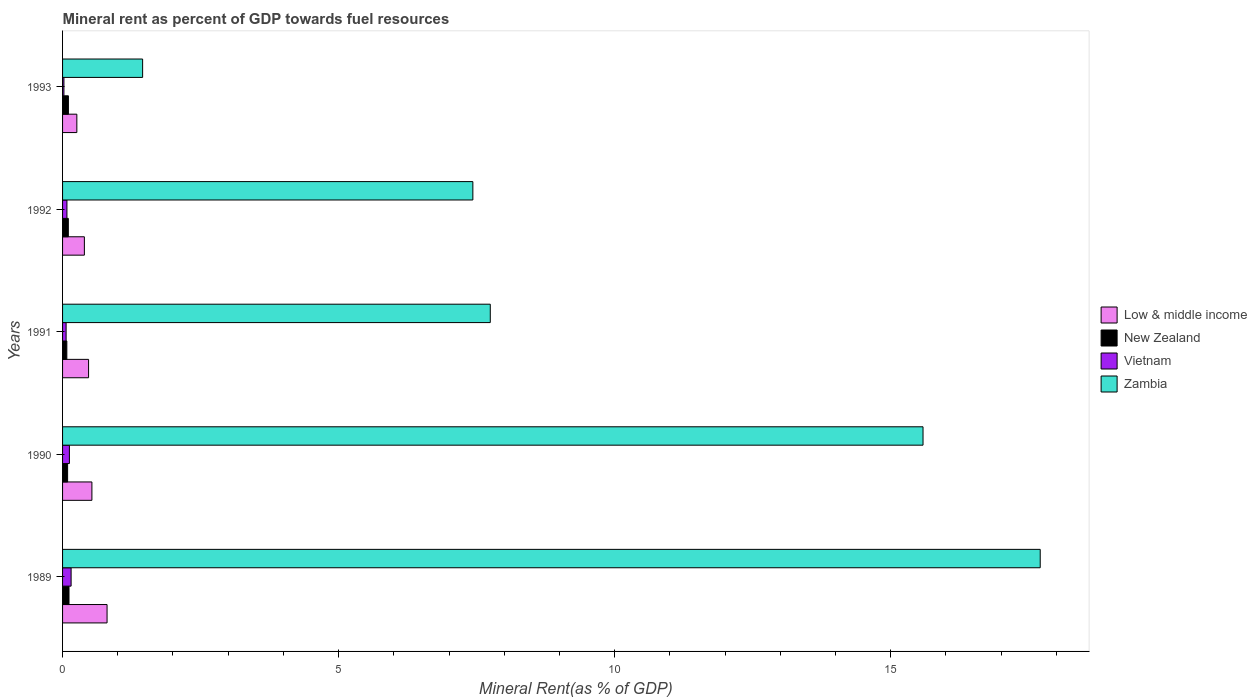How many different coloured bars are there?
Ensure brevity in your answer.  4. How many bars are there on the 3rd tick from the bottom?
Provide a succinct answer. 4. What is the mineral rent in Low & middle income in 1990?
Offer a very short reply. 0.53. Across all years, what is the maximum mineral rent in New Zealand?
Your response must be concise. 0.12. Across all years, what is the minimum mineral rent in Low & middle income?
Provide a short and direct response. 0.26. In which year was the mineral rent in Zambia maximum?
Give a very brief answer. 1989. What is the total mineral rent in Vietnam in the graph?
Provide a short and direct response. 0.45. What is the difference between the mineral rent in New Zealand in 1989 and that in 1993?
Give a very brief answer. 0.01. What is the difference between the mineral rent in Vietnam in 1992 and the mineral rent in Low & middle income in 1989?
Make the answer very short. -0.73. What is the average mineral rent in New Zealand per year?
Provide a succinct answer. 0.1. In the year 1993, what is the difference between the mineral rent in New Zealand and mineral rent in Zambia?
Make the answer very short. -1.34. In how many years, is the mineral rent in Zambia greater than 7 %?
Provide a succinct answer. 4. What is the ratio of the mineral rent in Low & middle income in 1990 to that in 1991?
Offer a very short reply. 1.13. What is the difference between the highest and the second highest mineral rent in Zambia?
Give a very brief answer. 2.12. What is the difference between the highest and the lowest mineral rent in Zambia?
Your answer should be compact. 16.26. What does the 1st bar from the top in 1993 represents?
Offer a terse response. Zambia. Is it the case that in every year, the sum of the mineral rent in Zambia and mineral rent in Low & middle income is greater than the mineral rent in Vietnam?
Offer a very short reply. Yes. How many bars are there?
Make the answer very short. 20. How many years are there in the graph?
Provide a short and direct response. 5. What is the difference between two consecutive major ticks on the X-axis?
Keep it short and to the point. 5. Are the values on the major ticks of X-axis written in scientific E-notation?
Ensure brevity in your answer.  No. Does the graph contain grids?
Your response must be concise. No. How are the legend labels stacked?
Offer a terse response. Vertical. What is the title of the graph?
Make the answer very short. Mineral rent as percent of GDP towards fuel resources. Does "Sweden" appear as one of the legend labels in the graph?
Your response must be concise. No. What is the label or title of the X-axis?
Your answer should be compact. Mineral Rent(as % of GDP). What is the label or title of the Y-axis?
Give a very brief answer. Years. What is the Mineral Rent(as % of GDP) of Low & middle income in 1989?
Ensure brevity in your answer.  0.81. What is the Mineral Rent(as % of GDP) in New Zealand in 1989?
Provide a succinct answer. 0.12. What is the Mineral Rent(as % of GDP) of Vietnam in 1989?
Your answer should be compact. 0.15. What is the Mineral Rent(as % of GDP) in Zambia in 1989?
Your response must be concise. 17.71. What is the Mineral Rent(as % of GDP) of Low & middle income in 1990?
Provide a succinct answer. 0.53. What is the Mineral Rent(as % of GDP) in New Zealand in 1990?
Keep it short and to the point. 0.09. What is the Mineral Rent(as % of GDP) of Vietnam in 1990?
Offer a terse response. 0.12. What is the Mineral Rent(as % of GDP) in Zambia in 1990?
Provide a succinct answer. 15.59. What is the Mineral Rent(as % of GDP) in Low & middle income in 1991?
Your answer should be very brief. 0.47. What is the Mineral Rent(as % of GDP) of New Zealand in 1991?
Your answer should be very brief. 0.08. What is the Mineral Rent(as % of GDP) in Vietnam in 1991?
Ensure brevity in your answer.  0.06. What is the Mineral Rent(as % of GDP) of Zambia in 1991?
Your answer should be very brief. 7.75. What is the Mineral Rent(as % of GDP) in Low & middle income in 1992?
Provide a succinct answer. 0.4. What is the Mineral Rent(as % of GDP) of New Zealand in 1992?
Your response must be concise. 0.1. What is the Mineral Rent(as % of GDP) of Vietnam in 1992?
Offer a terse response. 0.08. What is the Mineral Rent(as % of GDP) in Zambia in 1992?
Offer a terse response. 7.43. What is the Mineral Rent(as % of GDP) of Low & middle income in 1993?
Ensure brevity in your answer.  0.26. What is the Mineral Rent(as % of GDP) in New Zealand in 1993?
Keep it short and to the point. 0.11. What is the Mineral Rent(as % of GDP) of Vietnam in 1993?
Give a very brief answer. 0.02. What is the Mineral Rent(as % of GDP) in Zambia in 1993?
Keep it short and to the point. 1.45. Across all years, what is the maximum Mineral Rent(as % of GDP) of Low & middle income?
Ensure brevity in your answer.  0.81. Across all years, what is the maximum Mineral Rent(as % of GDP) of New Zealand?
Give a very brief answer. 0.12. Across all years, what is the maximum Mineral Rent(as % of GDP) of Vietnam?
Provide a short and direct response. 0.15. Across all years, what is the maximum Mineral Rent(as % of GDP) in Zambia?
Your response must be concise. 17.71. Across all years, what is the minimum Mineral Rent(as % of GDP) in Low & middle income?
Your answer should be very brief. 0.26. Across all years, what is the minimum Mineral Rent(as % of GDP) in New Zealand?
Make the answer very short. 0.08. Across all years, what is the minimum Mineral Rent(as % of GDP) in Vietnam?
Give a very brief answer. 0.02. Across all years, what is the minimum Mineral Rent(as % of GDP) of Zambia?
Provide a succinct answer. 1.45. What is the total Mineral Rent(as % of GDP) of Low & middle income in the graph?
Provide a short and direct response. 2.46. What is the total Mineral Rent(as % of GDP) of New Zealand in the graph?
Your answer should be very brief. 0.5. What is the total Mineral Rent(as % of GDP) of Vietnam in the graph?
Your answer should be compact. 0.45. What is the total Mineral Rent(as % of GDP) of Zambia in the graph?
Give a very brief answer. 49.92. What is the difference between the Mineral Rent(as % of GDP) of Low & middle income in 1989 and that in 1990?
Make the answer very short. 0.27. What is the difference between the Mineral Rent(as % of GDP) of New Zealand in 1989 and that in 1990?
Make the answer very short. 0.03. What is the difference between the Mineral Rent(as % of GDP) in Vietnam in 1989 and that in 1990?
Provide a succinct answer. 0.03. What is the difference between the Mineral Rent(as % of GDP) in Zambia in 1989 and that in 1990?
Ensure brevity in your answer.  2.12. What is the difference between the Mineral Rent(as % of GDP) of Low & middle income in 1989 and that in 1991?
Keep it short and to the point. 0.34. What is the difference between the Mineral Rent(as % of GDP) in New Zealand in 1989 and that in 1991?
Your answer should be very brief. 0.04. What is the difference between the Mineral Rent(as % of GDP) of Vietnam in 1989 and that in 1991?
Offer a very short reply. 0.09. What is the difference between the Mineral Rent(as % of GDP) in Zambia in 1989 and that in 1991?
Provide a succinct answer. 9.96. What is the difference between the Mineral Rent(as % of GDP) of Low & middle income in 1989 and that in 1992?
Give a very brief answer. 0.41. What is the difference between the Mineral Rent(as % of GDP) of New Zealand in 1989 and that in 1992?
Your answer should be very brief. 0.01. What is the difference between the Mineral Rent(as % of GDP) in Vietnam in 1989 and that in 1992?
Ensure brevity in your answer.  0.08. What is the difference between the Mineral Rent(as % of GDP) in Zambia in 1989 and that in 1992?
Your response must be concise. 10.28. What is the difference between the Mineral Rent(as % of GDP) in Low & middle income in 1989 and that in 1993?
Keep it short and to the point. 0.55. What is the difference between the Mineral Rent(as % of GDP) of New Zealand in 1989 and that in 1993?
Make the answer very short. 0.01. What is the difference between the Mineral Rent(as % of GDP) in Vietnam in 1989 and that in 1993?
Your answer should be compact. 0.13. What is the difference between the Mineral Rent(as % of GDP) in Zambia in 1989 and that in 1993?
Make the answer very short. 16.26. What is the difference between the Mineral Rent(as % of GDP) in Low & middle income in 1990 and that in 1991?
Your answer should be very brief. 0.06. What is the difference between the Mineral Rent(as % of GDP) of New Zealand in 1990 and that in 1991?
Offer a terse response. 0.01. What is the difference between the Mineral Rent(as % of GDP) in Vietnam in 1990 and that in 1991?
Keep it short and to the point. 0.06. What is the difference between the Mineral Rent(as % of GDP) of Zambia in 1990 and that in 1991?
Give a very brief answer. 7.84. What is the difference between the Mineral Rent(as % of GDP) of Low & middle income in 1990 and that in 1992?
Ensure brevity in your answer.  0.14. What is the difference between the Mineral Rent(as % of GDP) in New Zealand in 1990 and that in 1992?
Provide a succinct answer. -0.01. What is the difference between the Mineral Rent(as % of GDP) of Vietnam in 1990 and that in 1992?
Offer a terse response. 0.04. What is the difference between the Mineral Rent(as % of GDP) in Zambia in 1990 and that in 1992?
Make the answer very short. 8.15. What is the difference between the Mineral Rent(as % of GDP) in Low & middle income in 1990 and that in 1993?
Ensure brevity in your answer.  0.27. What is the difference between the Mineral Rent(as % of GDP) of New Zealand in 1990 and that in 1993?
Offer a terse response. -0.01. What is the difference between the Mineral Rent(as % of GDP) of Vietnam in 1990 and that in 1993?
Your answer should be very brief. 0.1. What is the difference between the Mineral Rent(as % of GDP) of Zambia in 1990 and that in 1993?
Your answer should be compact. 14.14. What is the difference between the Mineral Rent(as % of GDP) in Low & middle income in 1991 and that in 1992?
Your answer should be very brief. 0.08. What is the difference between the Mineral Rent(as % of GDP) of New Zealand in 1991 and that in 1992?
Offer a terse response. -0.03. What is the difference between the Mineral Rent(as % of GDP) in Vietnam in 1991 and that in 1992?
Offer a very short reply. -0.01. What is the difference between the Mineral Rent(as % of GDP) of Zambia in 1991 and that in 1992?
Provide a succinct answer. 0.32. What is the difference between the Mineral Rent(as % of GDP) of Low & middle income in 1991 and that in 1993?
Make the answer very short. 0.21. What is the difference between the Mineral Rent(as % of GDP) of New Zealand in 1991 and that in 1993?
Offer a terse response. -0.03. What is the difference between the Mineral Rent(as % of GDP) of Vietnam in 1991 and that in 1993?
Provide a short and direct response. 0.04. What is the difference between the Mineral Rent(as % of GDP) of Zambia in 1991 and that in 1993?
Offer a very short reply. 6.3. What is the difference between the Mineral Rent(as % of GDP) of Low & middle income in 1992 and that in 1993?
Provide a short and direct response. 0.14. What is the difference between the Mineral Rent(as % of GDP) in New Zealand in 1992 and that in 1993?
Offer a very short reply. -0. What is the difference between the Mineral Rent(as % of GDP) in Vietnam in 1992 and that in 1993?
Your response must be concise. 0.05. What is the difference between the Mineral Rent(as % of GDP) of Zambia in 1992 and that in 1993?
Make the answer very short. 5.98. What is the difference between the Mineral Rent(as % of GDP) of Low & middle income in 1989 and the Mineral Rent(as % of GDP) of New Zealand in 1990?
Your answer should be very brief. 0.71. What is the difference between the Mineral Rent(as % of GDP) in Low & middle income in 1989 and the Mineral Rent(as % of GDP) in Vietnam in 1990?
Your answer should be very brief. 0.68. What is the difference between the Mineral Rent(as % of GDP) of Low & middle income in 1989 and the Mineral Rent(as % of GDP) of Zambia in 1990?
Keep it short and to the point. -14.78. What is the difference between the Mineral Rent(as % of GDP) in New Zealand in 1989 and the Mineral Rent(as % of GDP) in Vietnam in 1990?
Provide a succinct answer. -0.01. What is the difference between the Mineral Rent(as % of GDP) in New Zealand in 1989 and the Mineral Rent(as % of GDP) in Zambia in 1990?
Your response must be concise. -15.47. What is the difference between the Mineral Rent(as % of GDP) in Vietnam in 1989 and the Mineral Rent(as % of GDP) in Zambia in 1990?
Provide a succinct answer. -15.43. What is the difference between the Mineral Rent(as % of GDP) in Low & middle income in 1989 and the Mineral Rent(as % of GDP) in New Zealand in 1991?
Your answer should be compact. 0.73. What is the difference between the Mineral Rent(as % of GDP) in Low & middle income in 1989 and the Mineral Rent(as % of GDP) in Vietnam in 1991?
Give a very brief answer. 0.74. What is the difference between the Mineral Rent(as % of GDP) in Low & middle income in 1989 and the Mineral Rent(as % of GDP) in Zambia in 1991?
Provide a short and direct response. -6.94. What is the difference between the Mineral Rent(as % of GDP) in New Zealand in 1989 and the Mineral Rent(as % of GDP) in Vietnam in 1991?
Provide a succinct answer. 0.05. What is the difference between the Mineral Rent(as % of GDP) in New Zealand in 1989 and the Mineral Rent(as % of GDP) in Zambia in 1991?
Make the answer very short. -7.63. What is the difference between the Mineral Rent(as % of GDP) in Vietnam in 1989 and the Mineral Rent(as % of GDP) in Zambia in 1991?
Give a very brief answer. -7.59. What is the difference between the Mineral Rent(as % of GDP) in Low & middle income in 1989 and the Mineral Rent(as % of GDP) in New Zealand in 1992?
Your answer should be compact. 0.7. What is the difference between the Mineral Rent(as % of GDP) of Low & middle income in 1989 and the Mineral Rent(as % of GDP) of Vietnam in 1992?
Your answer should be very brief. 0.73. What is the difference between the Mineral Rent(as % of GDP) in Low & middle income in 1989 and the Mineral Rent(as % of GDP) in Zambia in 1992?
Ensure brevity in your answer.  -6.63. What is the difference between the Mineral Rent(as % of GDP) in New Zealand in 1989 and the Mineral Rent(as % of GDP) in Vietnam in 1992?
Your response must be concise. 0.04. What is the difference between the Mineral Rent(as % of GDP) of New Zealand in 1989 and the Mineral Rent(as % of GDP) of Zambia in 1992?
Provide a short and direct response. -7.32. What is the difference between the Mineral Rent(as % of GDP) of Vietnam in 1989 and the Mineral Rent(as % of GDP) of Zambia in 1992?
Keep it short and to the point. -7.28. What is the difference between the Mineral Rent(as % of GDP) of Low & middle income in 1989 and the Mineral Rent(as % of GDP) of New Zealand in 1993?
Give a very brief answer. 0.7. What is the difference between the Mineral Rent(as % of GDP) in Low & middle income in 1989 and the Mineral Rent(as % of GDP) in Vietnam in 1993?
Give a very brief answer. 0.78. What is the difference between the Mineral Rent(as % of GDP) in Low & middle income in 1989 and the Mineral Rent(as % of GDP) in Zambia in 1993?
Ensure brevity in your answer.  -0.64. What is the difference between the Mineral Rent(as % of GDP) in New Zealand in 1989 and the Mineral Rent(as % of GDP) in Vietnam in 1993?
Provide a short and direct response. 0.09. What is the difference between the Mineral Rent(as % of GDP) in New Zealand in 1989 and the Mineral Rent(as % of GDP) in Zambia in 1993?
Provide a short and direct response. -1.33. What is the difference between the Mineral Rent(as % of GDP) in Vietnam in 1989 and the Mineral Rent(as % of GDP) in Zambia in 1993?
Offer a very short reply. -1.3. What is the difference between the Mineral Rent(as % of GDP) of Low & middle income in 1990 and the Mineral Rent(as % of GDP) of New Zealand in 1991?
Provide a succinct answer. 0.45. What is the difference between the Mineral Rent(as % of GDP) of Low & middle income in 1990 and the Mineral Rent(as % of GDP) of Vietnam in 1991?
Keep it short and to the point. 0.47. What is the difference between the Mineral Rent(as % of GDP) of Low & middle income in 1990 and the Mineral Rent(as % of GDP) of Zambia in 1991?
Provide a short and direct response. -7.22. What is the difference between the Mineral Rent(as % of GDP) in New Zealand in 1990 and the Mineral Rent(as % of GDP) in Vietnam in 1991?
Your answer should be very brief. 0.03. What is the difference between the Mineral Rent(as % of GDP) of New Zealand in 1990 and the Mineral Rent(as % of GDP) of Zambia in 1991?
Give a very brief answer. -7.66. What is the difference between the Mineral Rent(as % of GDP) in Vietnam in 1990 and the Mineral Rent(as % of GDP) in Zambia in 1991?
Provide a short and direct response. -7.62. What is the difference between the Mineral Rent(as % of GDP) of Low & middle income in 1990 and the Mineral Rent(as % of GDP) of New Zealand in 1992?
Provide a succinct answer. 0.43. What is the difference between the Mineral Rent(as % of GDP) of Low & middle income in 1990 and the Mineral Rent(as % of GDP) of Vietnam in 1992?
Provide a succinct answer. 0.45. What is the difference between the Mineral Rent(as % of GDP) in Low & middle income in 1990 and the Mineral Rent(as % of GDP) in Zambia in 1992?
Offer a terse response. -6.9. What is the difference between the Mineral Rent(as % of GDP) of New Zealand in 1990 and the Mineral Rent(as % of GDP) of Vietnam in 1992?
Offer a terse response. 0.01. What is the difference between the Mineral Rent(as % of GDP) of New Zealand in 1990 and the Mineral Rent(as % of GDP) of Zambia in 1992?
Your answer should be compact. -7.34. What is the difference between the Mineral Rent(as % of GDP) of Vietnam in 1990 and the Mineral Rent(as % of GDP) of Zambia in 1992?
Your response must be concise. -7.31. What is the difference between the Mineral Rent(as % of GDP) in Low & middle income in 1990 and the Mineral Rent(as % of GDP) in New Zealand in 1993?
Offer a terse response. 0.43. What is the difference between the Mineral Rent(as % of GDP) of Low & middle income in 1990 and the Mineral Rent(as % of GDP) of Vietnam in 1993?
Offer a terse response. 0.51. What is the difference between the Mineral Rent(as % of GDP) in Low & middle income in 1990 and the Mineral Rent(as % of GDP) in Zambia in 1993?
Your answer should be very brief. -0.92. What is the difference between the Mineral Rent(as % of GDP) in New Zealand in 1990 and the Mineral Rent(as % of GDP) in Vietnam in 1993?
Provide a succinct answer. 0.07. What is the difference between the Mineral Rent(as % of GDP) of New Zealand in 1990 and the Mineral Rent(as % of GDP) of Zambia in 1993?
Your response must be concise. -1.36. What is the difference between the Mineral Rent(as % of GDP) of Vietnam in 1990 and the Mineral Rent(as % of GDP) of Zambia in 1993?
Your response must be concise. -1.33. What is the difference between the Mineral Rent(as % of GDP) in Low & middle income in 1991 and the Mineral Rent(as % of GDP) in New Zealand in 1992?
Ensure brevity in your answer.  0.37. What is the difference between the Mineral Rent(as % of GDP) in Low & middle income in 1991 and the Mineral Rent(as % of GDP) in Vietnam in 1992?
Ensure brevity in your answer.  0.39. What is the difference between the Mineral Rent(as % of GDP) in Low & middle income in 1991 and the Mineral Rent(as % of GDP) in Zambia in 1992?
Provide a short and direct response. -6.96. What is the difference between the Mineral Rent(as % of GDP) in New Zealand in 1991 and the Mineral Rent(as % of GDP) in Vietnam in 1992?
Offer a terse response. -0. What is the difference between the Mineral Rent(as % of GDP) in New Zealand in 1991 and the Mineral Rent(as % of GDP) in Zambia in 1992?
Offer a terse response. -7.35. What is the difference between the Mineral Rent(as % of GDP) of Vietnam in 1991 and the Mineral Rent(as % of GDP) of Zambia in 1992?
Your response must be concise. -7.37. What is the difference between the Mineral Rent(as % of GDP) in Low & middle income in 1991 and the Mineral Rent(as % of GDP) in New Zealand in 1993?
Give a very brief answer. 0.37. What is the difference between the Mineral Rent(as % of GDP) in Low & middle income in 1991 and the Mineral Rent(as % of GDP) in Vietnam in 1993?
Provide a short and direct response. 0.45. What is the difference between the Mineral Rent(as % of GDP) in Low & middle income in 1991 and the Mineral Rent(as % of GDP) in Zambia in 1993?
Offer a terse response. -0.98. What is the difference between the Mineral Rent(as % of GDP) of New Zealand in 1991 and the Mineral Rent(as % of GDP) of Vietnam in 1993?
Offer a terse response. 0.05. What is the difference between the Mineral Rent(as % of GDP) of New Zealand in 1991 and the Mineral Rent(as % of GDP) of Zambia in 1993?
Your answer should be compact. -1.37. What is the difference between the Mineral Rent(as % of GDP) in Vietnam in 1991 and the Mineral Rent(as % of GDP) in Zambia in 1993?
Your answer should be very brief. -1.39. What is the difference between the Mineral Rent(as % of GDP) in Low & middle income in 1992 and the Mineral Rent(as % of GDP) in New Zealand in 1993?
Provide a short and direct response. 0.29. What is the difference between the Mineral Rent(as % of GDP) of Low & middle income in 1992 and the Mineral Rent(as % of GDP) of Vietnam in 1993?
Offer a terse response. 0.37. What is the difference between the Mineral Rent(as % of GDP) of Low & middle income in 1992 and the Mineral Rent(as % of GDP) of Zambia in 1993?
Your answer should be compact. -1.05. What is the difference between the Mineral Rent(as % of GDP) of New Zealand in 1992 and the Mineral Rent(as % of GDP) of Vietnam in 1993?
Offer a very short reply. 0.08. What is the difference between the Mineral Rent(as % of GDP) in New Zealand in 1992 and the Mineral Rent(as % of GDP) in Zambia in 1993?
Offer a terse response. -1.35. What is the difference between the Mineral Rent(as % of GDP) in Vietnam in 1992 and the Mineral Rent(as % of GDP) in Zambia in 1993?
Ensure brevity in your answer.  -1.37. What is the average Mineral Rent(as % of GDP) of Low & middle income per year?
Keep it short and to the point. 0.49. What is the average Mineral Rent(as % of GDP) of New Zealand per year?
Your response must be concise. 0.1. What is the average Mineral Rent(as % of GDP) of Vietnam per year?
Offer a terse response. 0.09. What is the average Mineral Rent(as % of GDP) of Zambia per year?
Make the answer very short. 9.98. In the year 1989, what is the difference between the Mineral Rent(as % of GDP) of Low & middle income and Mineral Rent(as % of GDP) of New Zealand?
Keep it short and to the point. 0.69. In the year 1989, what is the difference between the Mineral Rent(as % of GDP) in Low & middle income and Mineral Rent(as % of GDP) in Vietnam?
Provide a short and direct response. 0.65. In the year 1989, what is the difference between the Mineral Rent(as % of GDP) of Low & middle income and Mineral Rent(as % of GDP) of Zambia?
Offer a very short reply. -16.9. In the year 1989, what is the difference between the Mineral Rent(as % of GDP) of New Zealand and Mineral Rent(as % of GDP) of Vietnam?
Give a very brief answer. -0.04. In the year 1989, what is the difference between the Mineral Rent(as % of GDP) in New Zealand and Mineral Rent(as % of GDP) in Zambia?
Your response must be concise. -17.59. In the year 1989, what is the difference between the Mineral Rent(as % of GDP) of Vietnam and Mineral Rent(as % of GDP) of Zambia?
Your response must be concise. -17.55. In the year 1990, what is the difference between the Mineral Rent(as % of GDP) of Low & middle income and Mineral Rent(as % of GDP) of New Zealand?
Provide a short and direct response. 0.44. In the year 1990, what is the difference between the Mineral Rent(as % of GDP) of Low & middle income and Mineral Rent(as % of GDP) of Vietnam?
Provide a succinct answer. 0.41. In the year 1990, what is the difference between the Mineral Rent(as % of GDP) of Low & middle income and Mineral Rent(as % of GDP) of Zambia?
Offer a very short reply. -15.05. In the year 1990, what is the difference between the Mineral Rent(as % of GDP) in New Zealand and Mineral Rent(as % of GDP) in Vietnam?
Provide a succinct answer. -0.03. In the year 1990, what is the difference between the Mineral Rent(as % of GDP) in New Zealand and Mineral Rent(as % of GDP) in Zambia?
Provide a succinct answer. -15.49. In the year 1990, what is the difference between the Mineral Rent(as % of GDP) of Vietnam and Mineral Rent(as % of GDP) of Zambia?
Ensure brevity in your answer.  -15.46. In the year 1991, what is the difference between the Mineral Rent(as % of GDP) in Low & middle income and Mineral Rent(as % of GDP) in New Zealand?
Make the answer very short. 0.39. In the year 1991, what is the difference between the Mineral Rent(as % of GDP) of Low & middle income and Mineral Rent(as % of GDP) of Vietnam?
Offer a terse response. 0.41. In the year 1991, what is the difference between the Mineral Rent(as % of GDP) of Low & middle income and Mineral Rent(as % of GDP) of Zambia?
Keep it short and to the point. -7.28. In the year 1991, what is the difference between the Mineral Rent(as % of GDP) in New Zealand and Mineral Rent(as % of GDP) in Vietnam?
Give a very brief answer. 0.01. In the year 1991, what is the difference between the Mineral Rent(as % of GDP) of New Zealand and Mineral Rent(as % of GDP) of Zambia?
Your answer should be very brief. -7.67. In the year 1991, what is the difference between the Mineral Rent(as % of GDP) in Vietnam and Mineral Rent(as % of GDP) in Zambia?
Offer a very short reply. -7.68. In the year 1992, what is the difference between the Mineral Rent(as % of GDP) of Low & middle income and Mineral Rent(as % of GDP) of New Zealand?
Your response must be concise. 0.29. In the year 1992, what is the difference between the Mineral Rent(as % of GDP) in Low & middle income and Mineral Rent(as % of GDP) in Vietnam?
Your answer should be compact. 0.32. In the year 1992, what is the difference between the Mineral Rent(as % of GDP) of Low & middle income and Mineral Rent(as % of GDP) of Zambia?
Make the answer very short. -7.04. In the year 1992, what is the difference between the Mineral Rent(as % of GDP) of New Zealand and Mineral Rent(as % of GDP) of Vietnam?
Offer a very short reply. 0.03. In the year 1992, what is the difference between the Mineral Rent(as % of GDP) in New Zealand and Mineral Rent(as % of GDP) in Zambia?
Make the answer very short. -7.33. In the year 1992, what is the difference between the Mineral Rent(as % of GDP) of Vietnam and Mineral Rent(as % of GDP) of Zambia?
Your response must be concise. -7.35. In the year 1993, what is the difference between the Mineral Rent(as % of GDP) of Low & middle income and Mineral Rent(as % of GDP) of New Zealand?
Offer a very short reply. 0.15. In the year 1993, what is the difference between the Mineral Rent(as % of GDP) of Low & middle income and Mineral Rent(as % of GDP) of Vietnam?
Keep it short and to the point. 0.23. In the year 1993, what is the difference between the Mineral Rent(as % of GDP) in Low & middle income and Mineral Rent(as % of GDP) in Zambia?
Make the answer very short. -1.19. In the year 1993, what is the difference between the Mineral Rent(as % of GDP) in New Zealand and Mineral Rent(as % of GDP) in Vietnam?
Keep it short and to the point. 0.08. In the year 1993, what is the difference between the Mineral Rent(as % of GDP) in New Zealand and Mineral Rent(as % of GDP) in Zambia?
Make the answer very short. -1.34. In the year 1993, what is the difference between the Mineral Rent(as % of GDP) in Vietnam and Mineral Rent(as % of GDP) in Zambia?
Give a very brief answer. -1.43. What is the ratio of the Mineral Rent(as % of GDP) of Low & middle income in 1989 to that in 1990?
Give a very brief answer. 1.52. What is the ratio of the Mineral Rent(as % of GDP) in New Zealand in 1989 to that in 1990?
Keep it short and to the point. 1.28. What is the ratio of the Mineral Rent(as % of GDP) of Vietnam in 1989 to that in 1990?
Give a very brief answer. 1.25. What is the ratio of the Mineral Rent(as % of GDP) in Zambia in 1989 to that in 1990?
Ensure brevity in your answer.  1.14. What is the ratio of the Mineral Rent(as % of GDP) of Low & middle income in 1989 to that in 1991?
Ensure brevity in your answer.  1.71. What is the ratio of the Mineral Rent(as % of GDP) in New Zealand in 1989 to that in 1991?
Offer a very short reply. 1.51. What is the ratio of the Mineral Rent(as % of GDP) of Vietnam in 1989 to that in 1991?
Provide a short and direct response. 2.41. What is the ratio of the Mineral Rent(as % of GDP) in Zambia in 1989 to that in 1991?
Offer a terse response. 2.29. What is the ratio of the Mineral Rent(as % of GDP) in Low & middle income in 1989 to that in 1992?
Ensure brevity in your answer.  2.04. What is the ratio of the Mineral Rent(as % of GDP) of New Zealand in 1989 to that in 1992?
Offer a terse response. 1.12. What is the ratio of the Mineral Rent(as % of GDP) of Vietnam in 1989 to that in 1992?
Keep it short and to the point. 1.95. What is the ratio of the Mineral Rent(as % of GDP) of Zambia in 1989 to that in 1992?
Make the answer very short. 2.38. What is the ratio of the Mineral Rent(as % of GDP) of Low & middle income in 1989 to that in 1993?
Your response must be concise. 3.12. What is the ratio of the Mineral Rent(as % of GDP) in New Zealand in 1989 to that in 1993?
Provide a short and direct response. 1.1. What is the ratio of the Mineral Rent(as % of GDP) of Vietnam in 1989 to that in 1993?
Provide a succinct answer. 6.2. What is the ratio of the Mineral Rent(as % of GDP) of Zambia in 1989 to that in 1993?
Ensure brevity in your answer.  12.21. What is the ratio of the Mineral Rent(as % of GDP) in Low & middle income in 1990 to that in 1991?
Provide a succinct answer. 1.13. What is the ratio of the Mineral Rent(as % of GDP) of New Zealand in 1990 to that in 1991?
Your answer should be very brief. 1.18. What is the ratio of the Mineral Rent(as % of GDP) of Vietnam in 1990 to that in 1991?
Your answer should be compact. 1.93. What is the ratio of the Mineral Rent(as % of GDP) of Zambia in 1990 to that in 1991?
Offer a very short reply. 2.01. What is the ratio of the Mineral Rent(as % of GDP) in Low & middle income in 1990 to that in 1992?
Make the answer very short. 1.35. What is the ratio of the Mineral Rent(as % of GDP) in New Zealand in 1990 to that in 1992?
Your response must be concise. 0.88. What is the ratio of the Mineral Rent(as % of GDP) of Vietnam in 1990 to that in 1992?
Ensure brevity in your answer.  1.56. What is the ratio of the Mineral Rent(as % of GDP) in Zambia in 1990 to that in 1992?
Give a very brief answer. 2.1. What is the ratio of the Mineral Rent(as % of GDP) of Low & middle income in 1990 to that in 1993?
Your answer should be very brief. 2.06. What is the ratio of the Mineral Rent(as % of GDP) in New Zealand in 1990 to that in 1993?
Keep it short and to the point. 0.86. What is the ratio of the Mineral Rent(as % of GDP) in Vietnam in 1990 to that in 1993?
Your response must be concise. 4.97. What is the ratio of the Mineral Rent(as % of GDP) in Zambia in 1990 to that in 1993?
Offer a very short reply. 10.75. What is the ratio of the Mineral Rent(as % of GDP) in Low & middle income in 1991 to that in 1992?
Make the answer very short. 1.19. What is the ratio of the Mineral Rent(as % of GDP) of New Zealand in 1991 to that in 1992?
Provide a succinct answer. 0.74. What is the ratio of the Mineral Rent(as % of GDP) of Vietnam in 1991 to that in 1992?
Ensure brevity in your answer.  0.81. What is the ratio of the Mineral Rent(as % of GDP) in Zambia in 1991 to that in 1992?
Provide a succinct answer. 1.04. What is the ratio of the Mineral Rent(as % of GDP) in Low & middle income in 1991 to that in 1993?
Your response must be concise. 1.82. What is the ratio of the Mineral Rent(as % of GDP) of New Zealand in 1991 to that in 1993?
Your answer should be very brief. 0.73. What is the ratio of the Mineral Rent(as % of GDP) in Vietnam in 1991 to that in 1993?
Keep it short and to the point. 2.58. What is the ratio of the Mineral Rent(as % of GDP) in Zambia in 1991 to that in 1993?
Your response must be concise. 5.34. What is the ratio of the Mineral Rent(as % of GDP) of Low & middle income in 1992 to that in 1993?
Keep it short and to the point. 1.53. What is the ratio of the Mineral Rent(as % of GDP) of Vietnam in 1992 to that in 1993?
Your response must be concise. 3.18. What is the ratio of the Mineral Rent(as % of GDP) of Zambia in 1992 to that in 1993?
Provide a short and direct response. 5.13. What is the difference between the highest and the second highest Mineral Rent(as % of GDP) of Low & middle income?
Your response must be concise. 0.27. What is the difference between the highest and the second highest Mineral Rent(as % of GDP) in New Zealand?
Your answer should be very brief. 0.01. What is the difference between the highest and the second highest Mineral Rent(as % of GDP) of Vietnam?
Offer a very short reply. 0.03. What is the difference between the highest and the second highest Mineral Rent(as % of GDP) of Zambia?
Make the answer very short. 2.12. What is the difference between the highest and the lowest Mineral Rent(as % of GDP) of Low & middle income?
Provide a short and direct response. 0.55. What is the difference between the highest and the lowest Mineral Rent(as % of GDP) of New Zealand?
Offer a terse response. 0.04. What is the difference between the highest and the lowest Mineral Rent(as % of GDP) in Vietnam?
Provide a short and direct response. 0.13. What is the difference between the highest and the lowest Mineral Rent(as % of GDP) of Zambia?
Your answer should be compact. 16.26. 